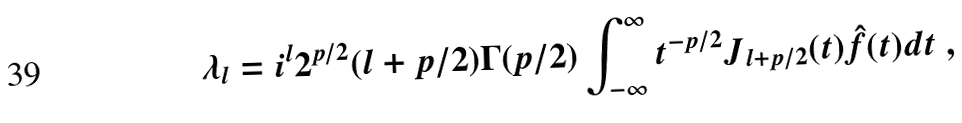Convert formula to latex. <formula><loc_0><loc_0><loc_500><loc_500>\lambda _ { l } = i ^ { l } 2 ^ { p / 2 } ( l + p / 2 ) \Gamma ( p / 2 ) \int _ { - \infty } ^ { \infty } t ^ { - p / 2 } J _ { l + p / 2 } ( t ) \hat { f } ( t ) d t \ ,</formula> 